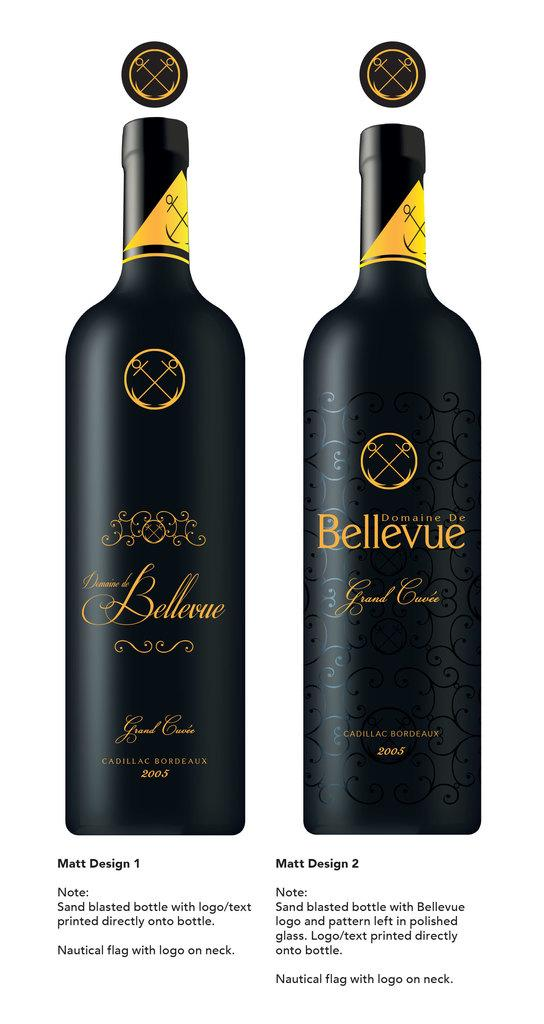<image>
Give a short and clear explanation of the subsequent image. Two designs for a bottle of Bellevue and a description of how it was done. 